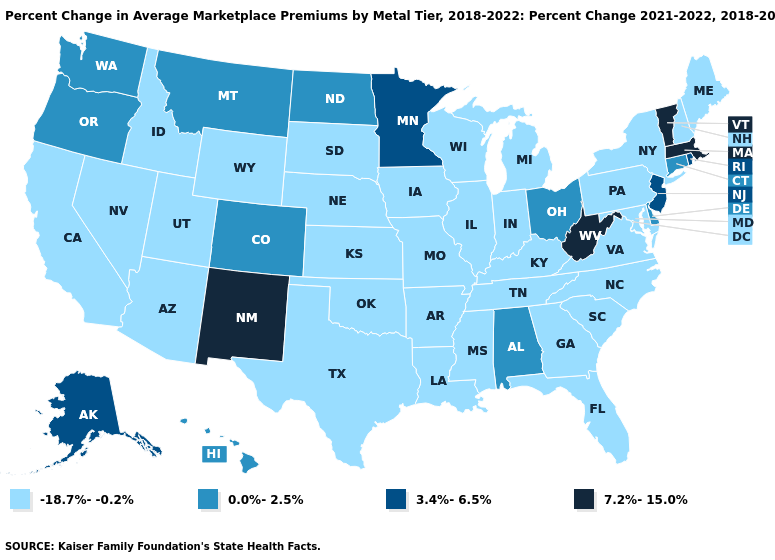What is the value of Texas?
Short answer required. -18.7%--0.2%. Which states have the highest value in the USA?
Quick response, please. Massachusetts, New Mexico, Vermont, West Virginia. Name the states that have a value in the range 7.2%-15.0%?
Quick response, please. Massachusetts, New Mexico, Vermont, West Virginia. Does California have a higher value than Arizona?
Answer briefly. No. Does the first symbol in the legend represent the smallest category?
Give a very brief answer. Yes. Name the states that have a value in the range -18.7%--0.2%?
Keep it brief. Arizona, Arkansas, California, Florida, Georgia, Idaho, Illinois, Indiana, Iowa, Kansas, Kentucky, Louisiana, Maine, Maryland, Michigan, Mississippi, Missouri, Nebraska, Nevada, New Hampshire, New York, North Carolina, Oklahoma, Pennsylvania, South Carolina, South Dakota, Tennessee, Texas, Utah, Virginia, Wisconsin, Wyoming. Which states have the highest value in the USA?
Short answer required. Massachusetts, New Mexico, Vermont, West Virginia. What is the value of Colorado?
Quick response, please. 0.0%-2.5%. What is the highest value in states that border Texas?
Concise answer only. 7.2%-15.0%. Which states hav the highest value in the Northeast?
Keep it brief. Massachusetts, Vermont. Does Idaho have the highest value in the USA?
Write a very short answer. No. What is the value of Maryland?
Give a very brief answer. -18.7%--0.2%. Which states have the highest value in the USA?
Quick response, please. Massachusetts, New Mexico, Vermont, West Virginia. Which states have the highest value in the USA?
Answer briefly. Massachusetts, New Mexico, Vermont, West Virginia. What is the value of Idaho?
Give a very brief answer. -18.7%--0.2%. 